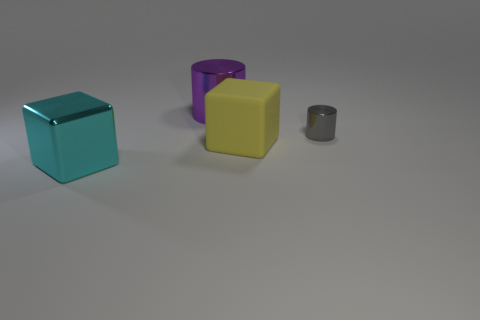Are there any other things that have the same material as the big yellow block?
Keep it short and to the point. No. How many other objects are the same shape as the matte object?
Your answer should be very brief. 1. How many shiny things are either purple cylinders or tiny gray objects?
Your response must be concise. 2. What is the material of the block to the right of the big shiny thing in front of the gray metal cylinder?
Your answer should be compact. Rubber. Are there more yellow cubes in front of the tiny shiny cylinder than red balls?
Offer a terse response. Yes. Is there a small cyan sphere that has the same material as the large yellow thing?
Offer a terse response. No. There is a big metal object that is behind the big cyan shiny cube; is its shape the same as the cyan metallic object?
Make the answer very short. No. What number of purple metal objects are to the right of the block to the left of the big shiny object behind the tiny metallic cylinder?
Provide a succinct answer. 1. Are there fewer big purple things in front of the large cyan metal object than large cyan objects right of the big yellow matte block?
Provide a short and direct response. No. There is a small object that is the same shape as the big purple object; what is its color?
Offer a very short reply. Gray. 